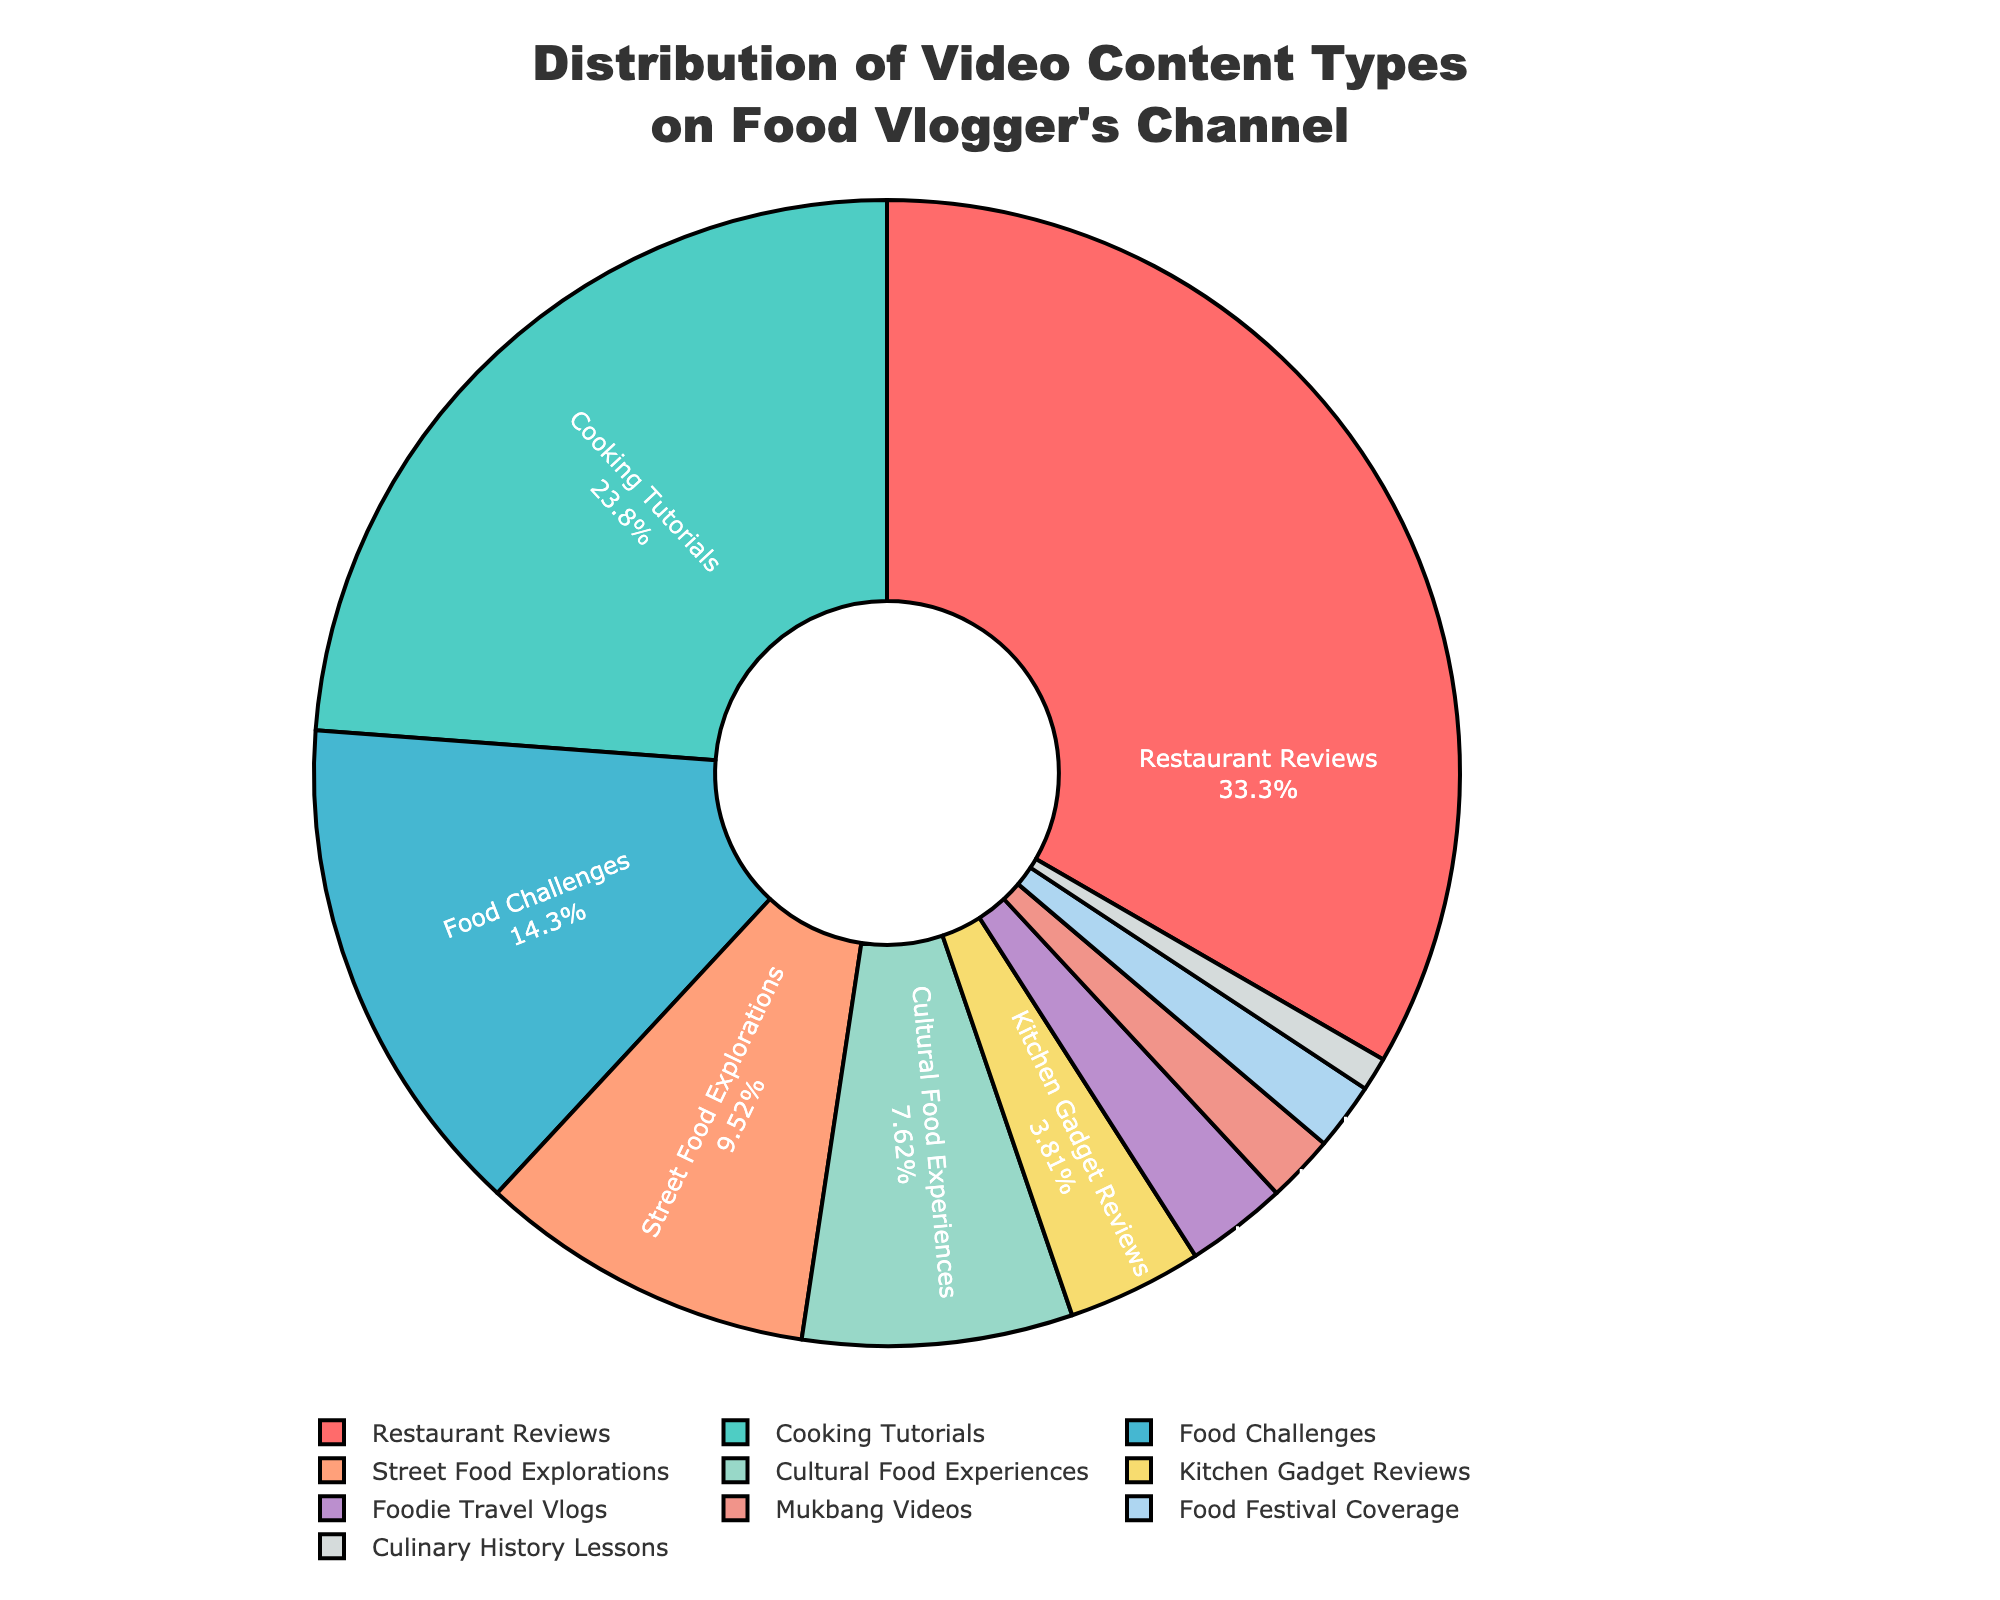What's the largest content type on the pie chart? The largest content type can be identified by looking for the segment that takes up the most space visually. In the pie chart, the "Restaurant Reviews" section occupies the largest portion.
Answer: Restaurant Reviews Which content type has the second-largest share? To find the second-largest share, we look for the segment just smaller than the largest one. "Cooking Tutorials" occupies the second-largest portion after "Restaurant Reviews."
Answer: Cooking Tutorials What is the combined percentage of "Street Food Explorations" and "Cultural Food Experiences"? Adding the percentages from the pie chart: "Street Food Explorations" (10%) + "Cultural Food Experiences" (8%). This adds up to 18%.
Answer: 18% Are "Food Challenges" more popular than "Street Food Explorations"? By comparing the percentages: "Food Challenges" (15%) vs. "Street Food Explorations" (10%), we see that "Food Challenges" has a higher percentage.
Answer: Yes What's the percentage difference between "Restaurant Reviews" and "Food Challenges"? Subtract the percentage of "Food Challenges" from "Restaurant Reviews": 35% - 15% = 20%.
Answer: 20% Which content type is represented by a color that is likely to be red? The color palette used in the pie chart suggests that "Restaurant Reviews," which usually are emphasized, might be represented by red.
Answer: Restaurant Reviews What is the total percentage for all content types less than 5%? Adding the percentages of content types less than 5%: "Kitchen Gadget Reviews" (4%) + "Foodie Travel Vlogs" (3%) + "Mukbang Videos" (2%) + "Food Festival Coverage" (2%) + "Culinary History Lessons" (1%) = 12%.
Answer: 12% Which content type occupies the least space on the pie chart? The smallest segment on the pie chart represents "Culinary History Lessons" which has a percentage of 1%.
Answer: Culinary History Lessons Is the sum of "Cooking Tutorials" and "Food Challenges" greater than "Restaurant Reviews"? Adding the percentages of "Cooking Tutorials" (25%) + "Food Challenges" (15%) = 40%, which is greater than "Restaurant Reviews" (35%).
Answer: Yes What colors are used to represent "Food Challenges" and "Cultural Food Experiences"? Referring to the custom color palette in the pie chart, "Food Challenges" might be represented by a different greenish-blue color while "Cultural Food Experiences" could be a softer color.
Answer: Greenish-blue and light color 